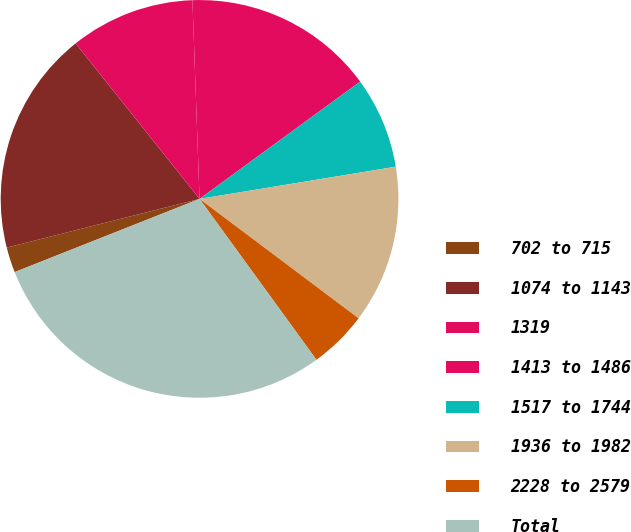Convert chart. <chart><loc_0><loc_0><loc_500><loc_500><pie_chart><fcel>702 to 715<fcel>1074 to 1143<fcel>1319<fcel>1413 to 1486<fcel>1517 to 1744<fcel>1936 to 1982<fcel>2228 to 2579<fcel>Total<nl><fcel>2.06%<fcel>18.23%<fcel>10.14%<fcel>15.53%<fcel>7.45%<fcel>12.84%<fcel>4.75%<fcel>29.0%<nl></chart> 